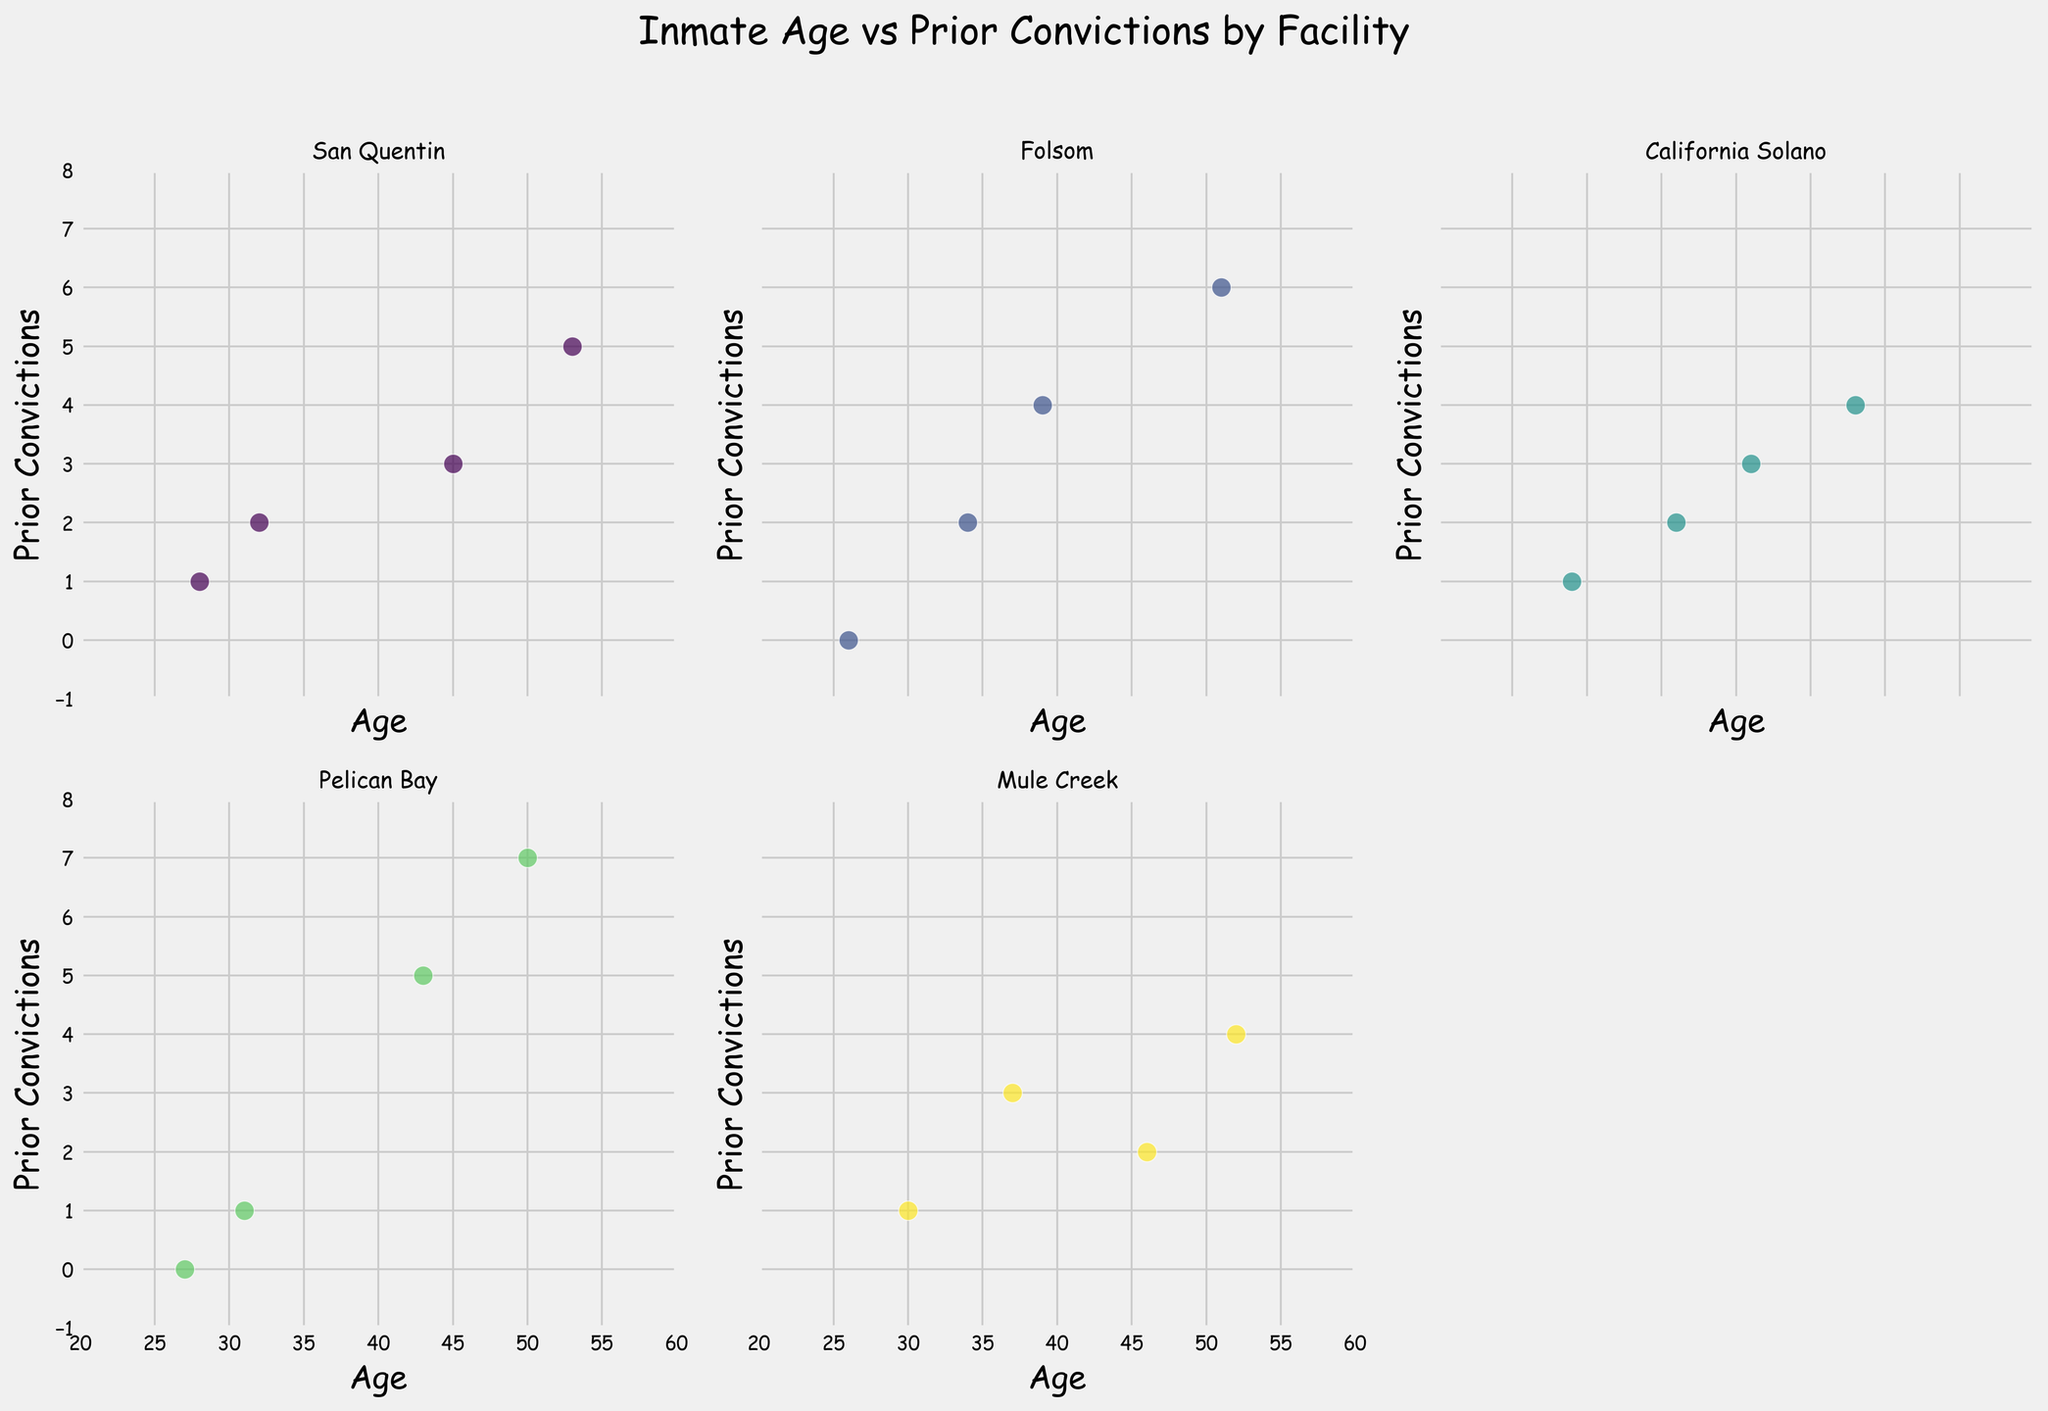What's the title of the figure? The title of the figure is typically located at the top of the plot, summarizing its content. Here, it indicates the relationship between ages and prior convictions of inmates in different facilities.
Answer: Inmate Age vs Prior Convictions by Facility How many subplots are in the figure? By counting the number of distinct scatter plots, we can see there are five plots corresponding to five correctional facilities.
Answer: 5 What is the x-axis label? The x-axis label describes the horizontal axis of the plot, indicating what variable is being measured. Here, it is "Age."
Answer: Age Which facility has inmates with the widest age range? We analyze the span of data points along the x-axis in each subplot. San Quentin State Prison has data points from age 28 to 53, indicating the widest range.
Answer: San Quentin State Prison Which facility has the highest number of prior convictions recorded for an inmate? By looking at the y-axis values in each subplot, Pelican Bay State Prison has the highest value at 7 prior convictions.
Answer: Pelican Bay State Prison What is the age of the inmate with the highest number of prior convictions? In Pelican Bay State Prison's subplot, the data point with the highest y-value (7) corresponds to an age, which is 50.
Answer: 50 Which facility has the youngest inmate with no prior convictions? We look for the lowest age value with y=0 across the subplots. Folsom State Prison has an inmate aged 26 with no prior convictions.
Answer: Folsom State Prison How many inmates at Mule Creek State Prison have 3 prior convictions? In Mule Creek State Prison's subplot, there is one data point at (37, 3) indicating that one inmate has 3 prior convictions.
Answer: 1 What is the average age of inmates at California State Prison Solano? Calculate the mean of the ages for California State Prison Solano data points: (41 + 29 + 48 + 36) / 4 = 154 / 4 = 38.5
Answer: 38.5 Which facility has the most inmates with exactly 1 prior conviction? By counting the data points at y=1 in each subplot, both San Quentin State Prison and Mule Creek State Prison have two inmates each with exactly 1 prior conviction.
Answer: San Quentin State Prison & Mule Creek State Prison 